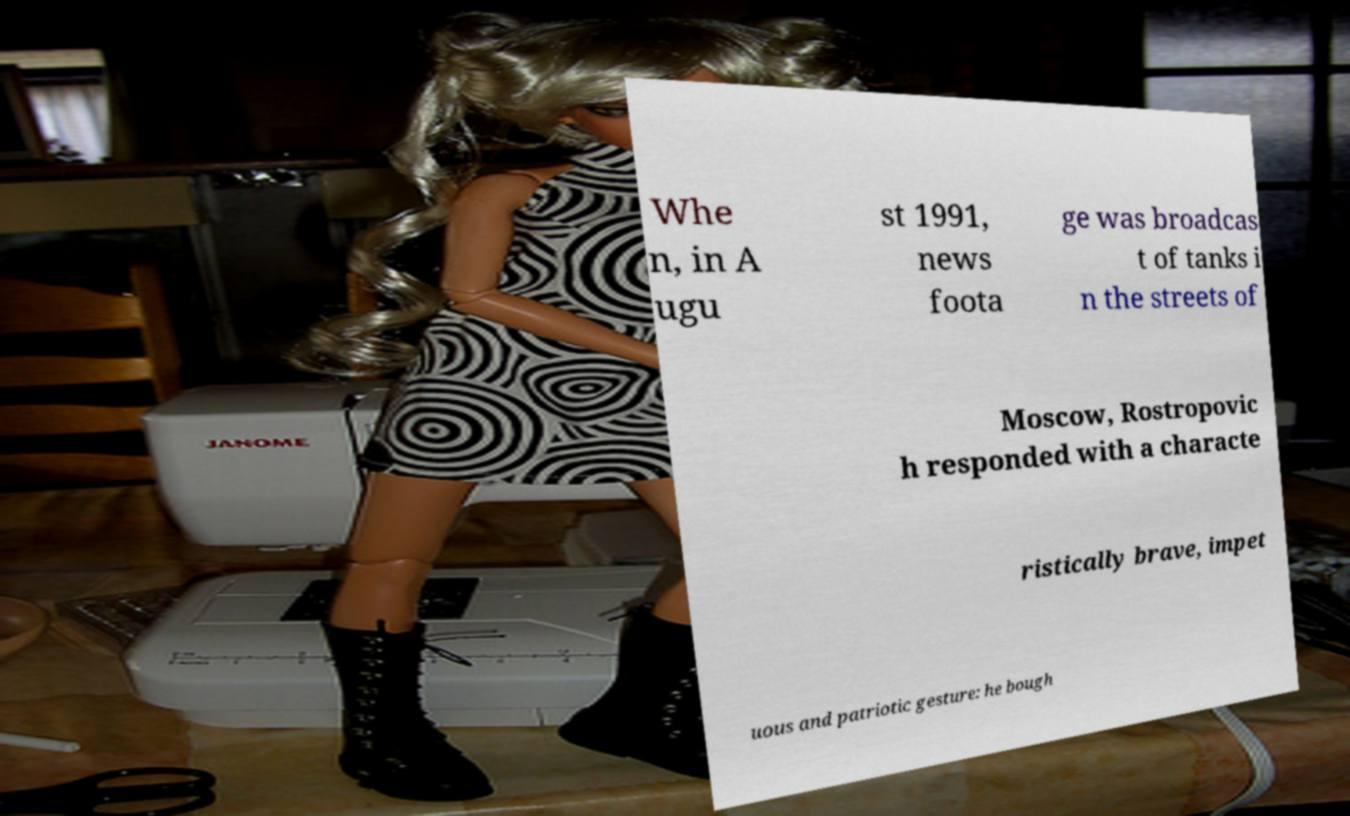Can you read and provide the text displayed in the image?This photo seems to have some interesting text. Can you extract and type it out for me? Whe n, in A ugu st 1991, news foota ge was broadcas t of tanks i n the streets of Moscow, Rostropovic h responded with a characte ristically brave, impet uous and patriotic gesture: he bough 